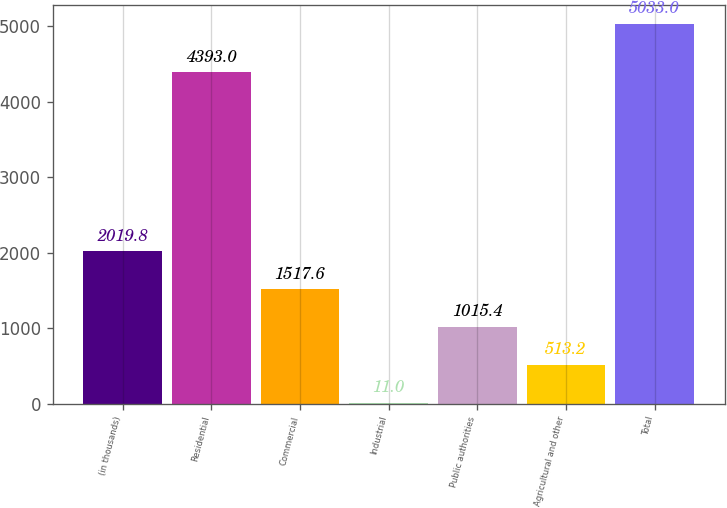Convert chart. <chart><loc_0><loc_0><loc_500><loc_500><bar_chart><fcel>(in thousands)<fcel>Residential<fcel>Commercial<fcel>Industrial<fcel>Public authorities<fcel>Agricultural and other<fcel>Total<nl><fcel>2019.8<fcel>4393<fcel>1517.6<fcel>11<fcel>1015.4<fcel>513.2<fcel>5033<nl></chart> 